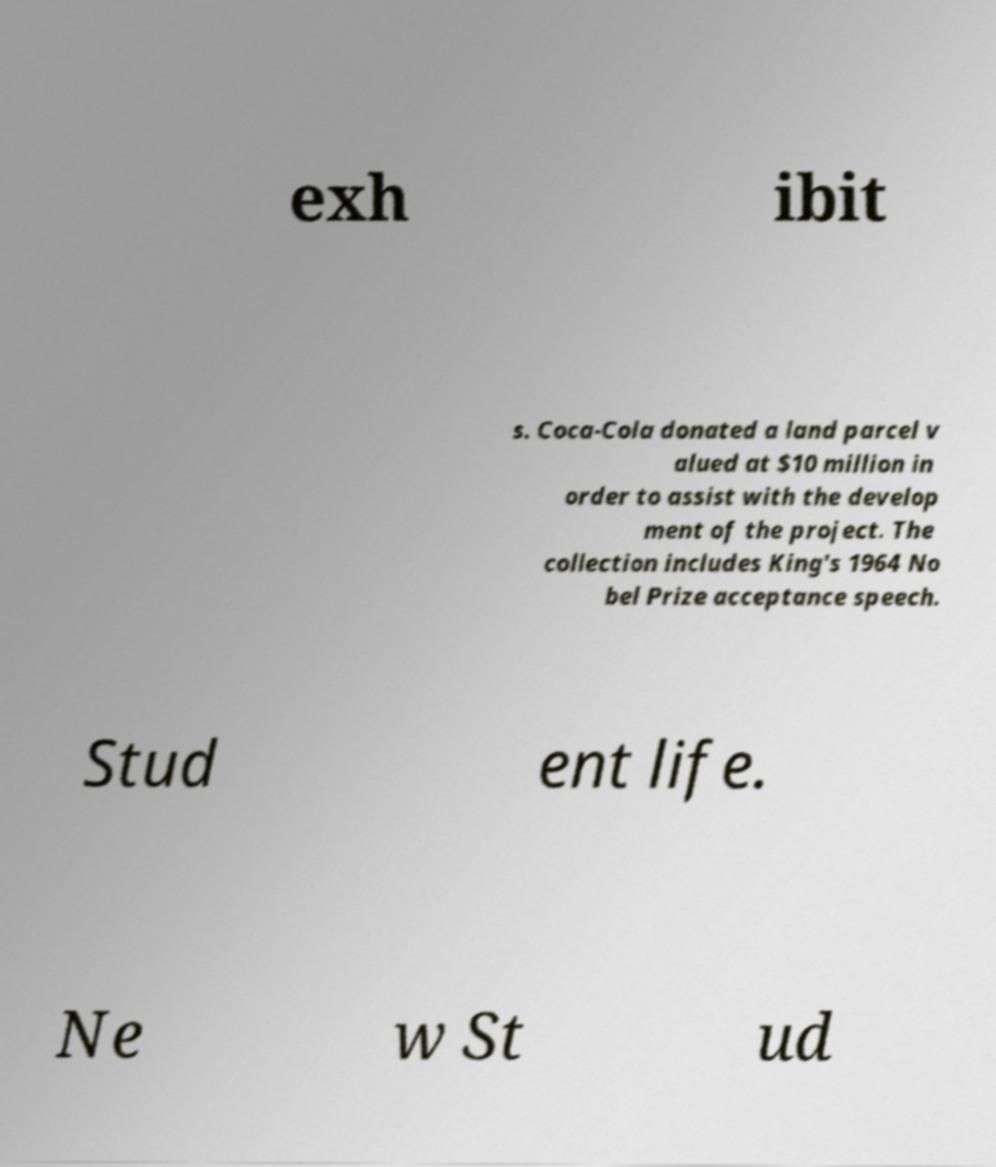There's text embedded in this image that I need extracted. Can you transcribe it verbatim? exh ibit s. Coca-Cola donated a land parcel v alued at $10 million in order to assist with the develop ment of the project. The collection includes King's 1964 No bel Prize acceptance speech. Stud ent life. Ne w St ud 